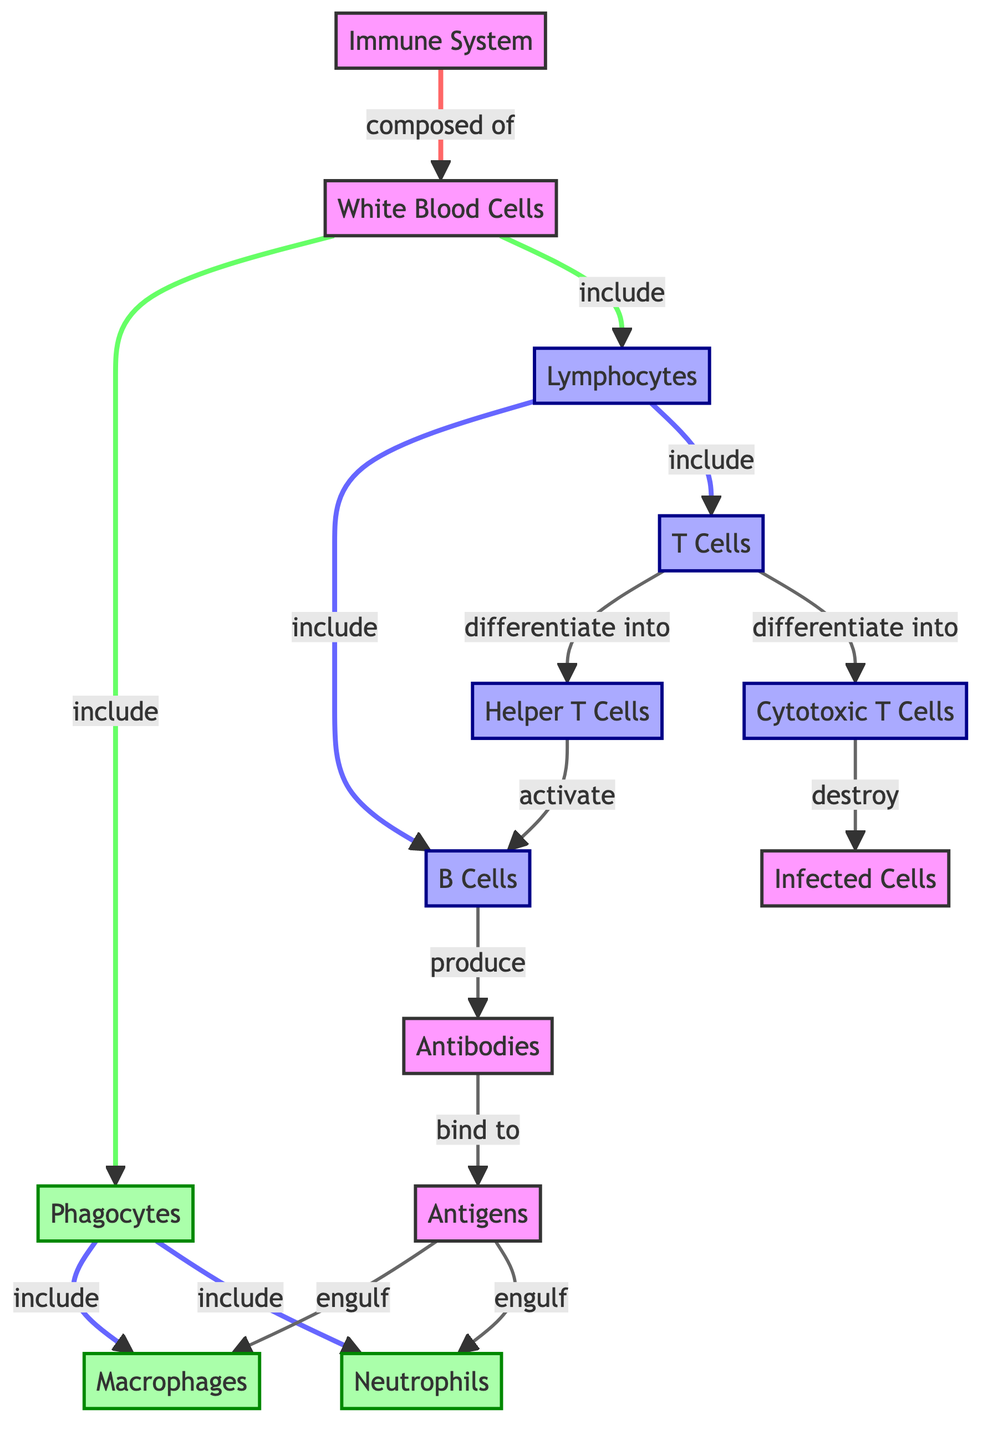What are the two main types of White Blood Cells shown? The diagram clearly separates White Blood Cells into two distinct categories: Phagocytes and Lymphocytes, which are labeled directly under the "White Blood Cells" node.
Answer: Phagocytes and Lymphocytes How many types of Phagocytes are included in the diagram? The diagram lists two specific types of Phagocytes: Macrophages and Neutrophils, which are both included under the Phagocytes node.
Answer: 2 What do B Cells produce? According to the diagram, B Cells are indicated to produce Antibodies, as shown by the directional relationship from B Cells to the Antibodies node.
Answer: Antibodies Which type of T Cells activates B Cells? The diagram specifies that Helper T Cells activate B Cells, denoted by a directional arrow that indicates the relationship between Helper T Cells and B Cells.
Answer: Helper T Cells What do Cytotoxic T Cells destroy? The diagram indicates that Cytotoxic T Cells are responsible for destroying Infected Cells, as depicted by the arrow leading from Cytotoxic T Cells to Infected Cells.
Answer: Infected Cells How many nodes are under the Lymphocytes category? The diagram categorizes Lymphocytes into three distinct types: B Cells, T Cells, and indicates further differentiation into Helper T Cells and Cytotoxic T Cells, amounting to four nodes in total under Lymphocytes.
Answer: 4 What role do Antibodies play according to the diagram? The diagram illustrates that Antibodies bind to Antigens, indicating that this is their primary role within the immune response, as shown by the connecting arrow from Antibodies to Antigens.
Answer: Bind to Antigens Which cells engulf Antigens, according to the diagram? The diagram points out that both Macrophages and Neutrophils engage in the engulfing process of Antigens, as indicated by the arrows linking Antigens to these two types of Phagocytes.
Answer: Macrophages and Neutrophils 